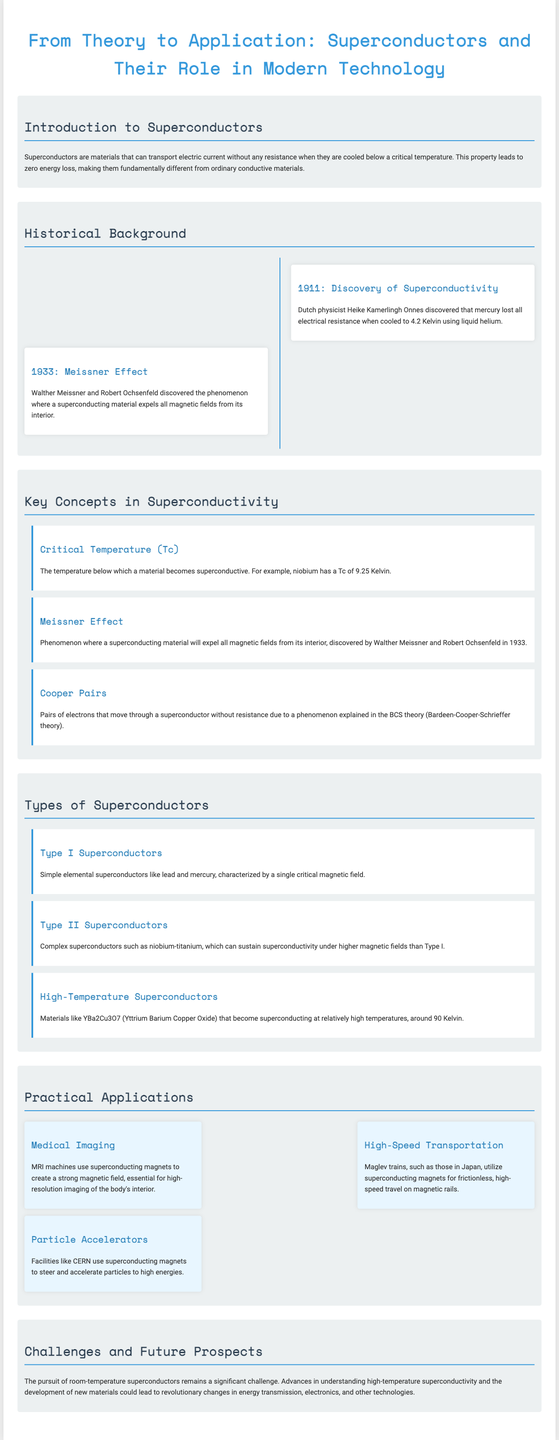What is the critical temperature of niobium? The critical temperature of niobium is given in the document as 9.25 Kelvin.
Answer: 9.25 Kelvin Who discovered superconductivity? The discovery of superconductivity is credited to Dutch physicist Heike Kamerlingh Onnes.
Answer: Heike Kamerlingh Onnes What year did the Meissner Effect get discovered? The year in which the Meissner Effect was discovered is stated as 1933.
Answer: 1933 What application uses superconducting magnets in medical technology? The application mentioned in the document that uses superconducting magnets in medical technology is MRI machines.
Answer: MRI machines What distinguishes Type II superconductors from Type I? Type II superconductors can sustain superconductivity under higher magnetic fields than Type I.
Answer: Higher magnetic fields What is the main challenge mentioned in the document regarding superconductors? The main challenge mentioned is the pursuit of room-temperature superconductors.
Answer: Room-temperature superconductors What is the significance of Cooper pairs in superconductivity? Cooper pairs are significant because they allow electrons to move through a superconductor without resistance.
Answer: Move without resistance Which high-temperature superconductor is listed in the document? The high-temperature superconductor listed is YBa2Cu3O7.
Answer: YBa2Cu3O7 How are superconductors relevant to particle accelerators? Superconductors are used in particle accelerators to steer and accelerate particles to high energies.
Answer: Steer and accelerate particles 